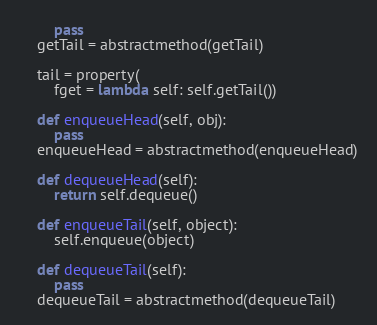<code> <loc_0><loc_0><loc_500><loc_500><_Python_>        pass
    getTail = abstractmethod(getTail)

    tail = property(
        fget = lambda self: self.getTail())

    def enqueueHead(self, obj):
        pass
    enqueueHead = abstractmethod(enqueueHead)

    def dequeueHead(self):
        return self.dequeue()

    def enqueueTail(self, object):
        self.enqueue(object)

    def dequeueTail(self):
        pass
    dequeueTail = abstractmethod(dequeueTail)
</code> 